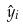<formula> <loc_0><loc_0><loc_500><loc_500>\hat { y } _ { i }</formula> 